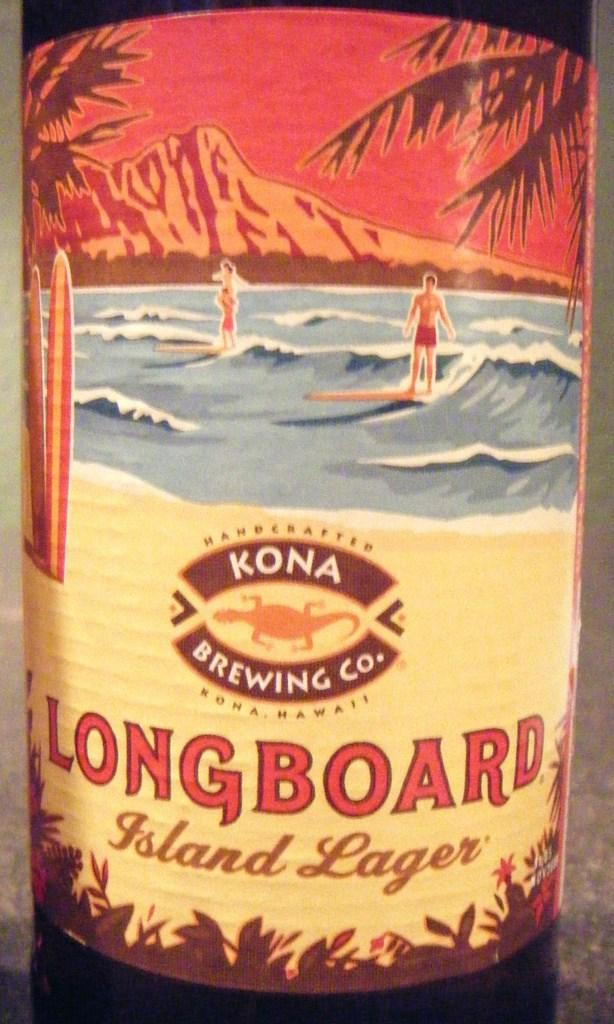<image>
Describe the image concisely. A bottle of Kona Longboard feature two men surfing on the label 